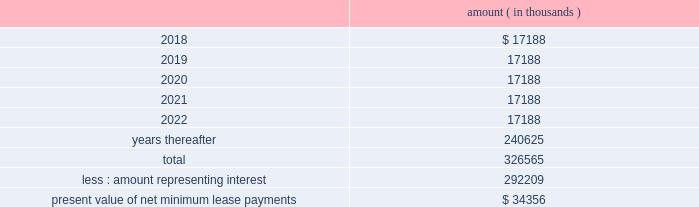As of december a031 , 2017 , system energy , in connection with the grand gulf sale and leaseback transactions , had future minimum lease payments ( reflecting an implicit rate of 5.13% ( 5.13 % ) ) that are recorded as long-term debt , as follows : amount ( in thousands ) .
Entergy corporation and subsidiaries notes to financial statements note 11 . a0 retirement , other postretirement benefits , and defined contribution plans a0 a0 ( entergy corporation , entergy arkansas , entergy louisiana , entergy mississippi , entergy new orleans , entergy texas , and system energy ) qualified pension plans entergy has eight qualified pension plans covering substantially all employees .
The entergy corporation retirement plan for non-bargaining employees ( non-bargaining plan i ) , the entergy corporation retirement plan for bargaining employees ( bargaining plan i ) , the entergy corporation retirement plan ii for non-bargaining employees ( non-bargaining plan ii ) , the entergy corporation retirement plan ii for bargaining employees , the entergy corporation retirement plan iii , and the entergy corporation retirement plan iv for bargaining employees a0are non-contributory final average pay plans and provide pension benefits that are based on employees 2019 credited service and compensation during employment .
Effective as of the close of business on december 31 , 2016 , the entergy corporation retirement plan iv for non-bargaining employees ( non-bargaining plan iv ) was merged with and into non-bargaining plan ii .
At the close of business on december 31 , 2016 , the liabilities for the accrued benefits and the assets attributable to such liabilities of all participants in non-bargaining plan iv were assumed by and transferred to non-bargaining plan ii .
There was no loss of vesting or benefit options or reduction of accrued benefits to affected participants as a result of this plan merger .
Non-bargaining employees whose most recent date of hire is after june 30 , 2014 participate in the entergy corporation cash balance plan for non-bargaining employees ( non-bargaining cash balance plan ) .
Certain bargaining employees hired or rehired after june 30 , 2014 , or such later date provided for in their applicable collective bargaining agreements , participate in the entergy corporation cash balance plan for bargaining employees ( bargaining cash balance plan ) .
The registrant subsidiaries participate in these four plans : non-bargaining plan i , bargaining plan i , non-bargaining cash balance plan , and bargaining cash balance plan .
The assets of the six final average pay qualified pension plans are held in a master trust established by entergy , and the assets of the two cash balance pension plans are held in a second master trust established by entergy . a0 a0each pension plan has an undivided beneficial interest in each of the investment accounts in its respective master trust that is maintained by a trustee . a0 a0use of the master trusts permits the commingling of the trust assets of the pension plans of entergy corporation and its registrant subsidiaries for investment and administrative purposes . a0 a0although assets in the master trusts are commingled , the trustee maintains supporting records for the purpose of allocating the trust level equity in net earnings ( loss ) and the administrative expenses of the investment accounts in each trust to the various participating pension plans in that particular trust . a0 a0the fair value of the trusts 2019 assets is determined by the trustee and certain investment managers . a0 a0for each trust , the trustee calculates a daily earnings factor , including realized and .
What is the present value of net minimum lease payments as a percentage of the total future minimum lease payments ? 
Computations: (34356 / 326565)
Answer: 0.1052. 